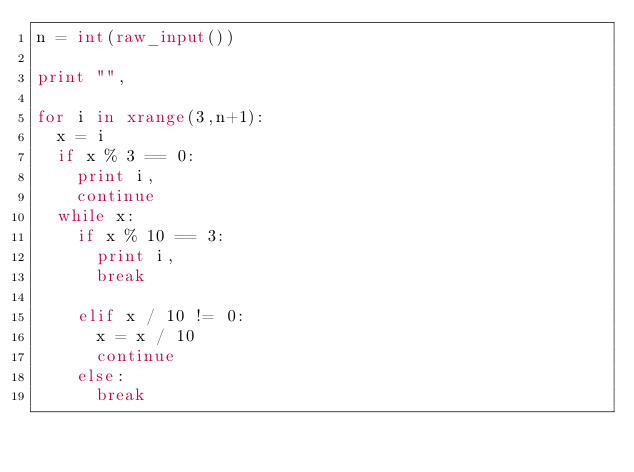Convert code to text. <code><loc_0><loc_0><loc_500><loc_500><_Python_>n = int(raw_input())

print "",

for i in xrange(3,n+1):
	x = i
	if x % 3 == 0:
		print i,
		continue
	while x:
		if x % 10 == 3:
			print i,
			break

		elif x / 10 != 0:
			x = x / 10
			continue
		else:
			break</code> 